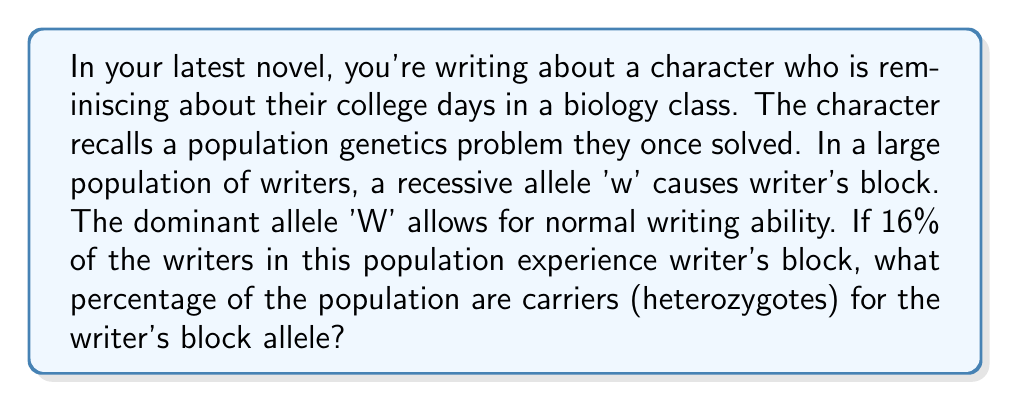Can you answer this question? Let's approach this step-by-step using the Hardy-Weinberg principle:

1) First, we need to identify our alleles:
   W = normal writing ability (dominant)
   w = writer's block (recessive)

2) We're told that 16% of the population experiences writer's block. These are the homozygous recessive individuals (ww). In Hardy-Weinberg terms, this is $q^2 = 0.16$

3) To find q (the frequency of the recessive allele):
   $q = \sqrt{0.16} = 0.4$

4) The frequency of the dominant allele (p) is:
   $p = 1 - q = 1 - 0.4 = 0.6$

5) Now, we can use the Hardy-Weinberg equation to find the frequency of heterozygotes:
   $2pq = 2(0.6)(0.4) = 0.48$

6) To convert to a percentage, we multiply by 100:
   $0.48 * 100 = 48\%$

This problem mirrors the kind of population genetics questions the character might have encountered in their college biology class, providing a realistic backdrop for the novel's narrative.
Answer: 48% of the population are carriers (heterozygotes) for the writer's block allele. 